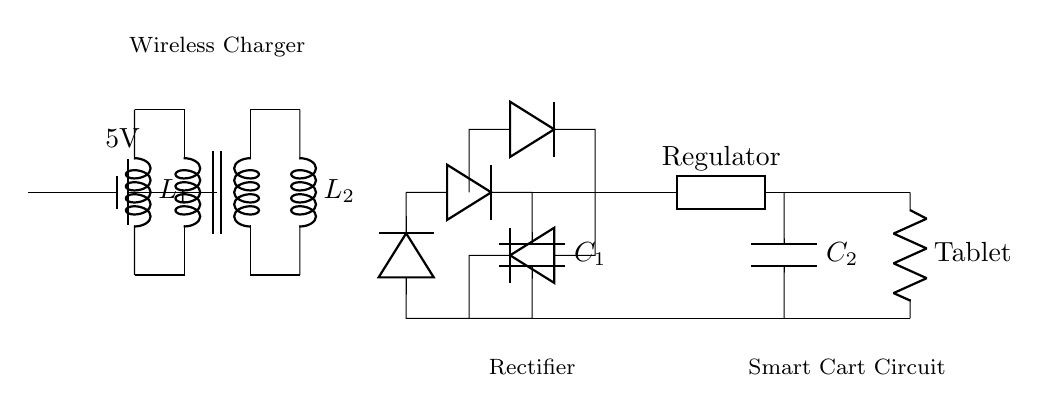What components are present in the wireless charging circuit? The circuit contains a transformer, inductors, diodes, capacitors, a voltage regulator, and a resistive load labeled as Tablet. Each element plays a specific role in the charging process.
Answer: transformer, inductors, diodes, capacitors, voltage regulator, load What is the voltage of the power source? The power source is labeled as 5V, indicating that it supplies a potential difference of five volts to the circuit.
Answer: 5V What is the role of the rectifier in this circuit? The rectifier, which consists of diodes, converts the alternating current produced by the transformer into direct current suitable for charging. This conversion is essential for the functionality of the charging system.
Answer: converts AC to DC How many capacitors are present in the circuit? There are two capacitors labeled C1 and C2 within the circuit. These capacitors help smooth the voltage and storage of electrical energy for the load, ensuring stable operation.
Answer: 2 What is the primary purpose of the voltage regulator in this circuit? The voltage regulator is used to maintain a stable output voltage level despite variations in load current or input voltage. This regulation ensures that the tablet receives the appropriate voltage required for operation, which is critical for proper functioning.
Answer: maintains stable voltage What type of load is indicated in the circuit diagram? The load in the circuit is labeled as Tablet, suggesting that it refers to a device like a tablet computer which requires charging. The specific labeling indicates that the load component is designed to operate with the circuit’s output.
Answer: Tablet What is the relationship between the transformer and inductors in this circuit? The transformer consists of two inductors, L1 and L2, which work together to transfer energy wirelessly from the primary side to the secondary side through magnetic coupling. This relationship is fundamental in wireless charging technologies.
Answer: magnetic coupling 